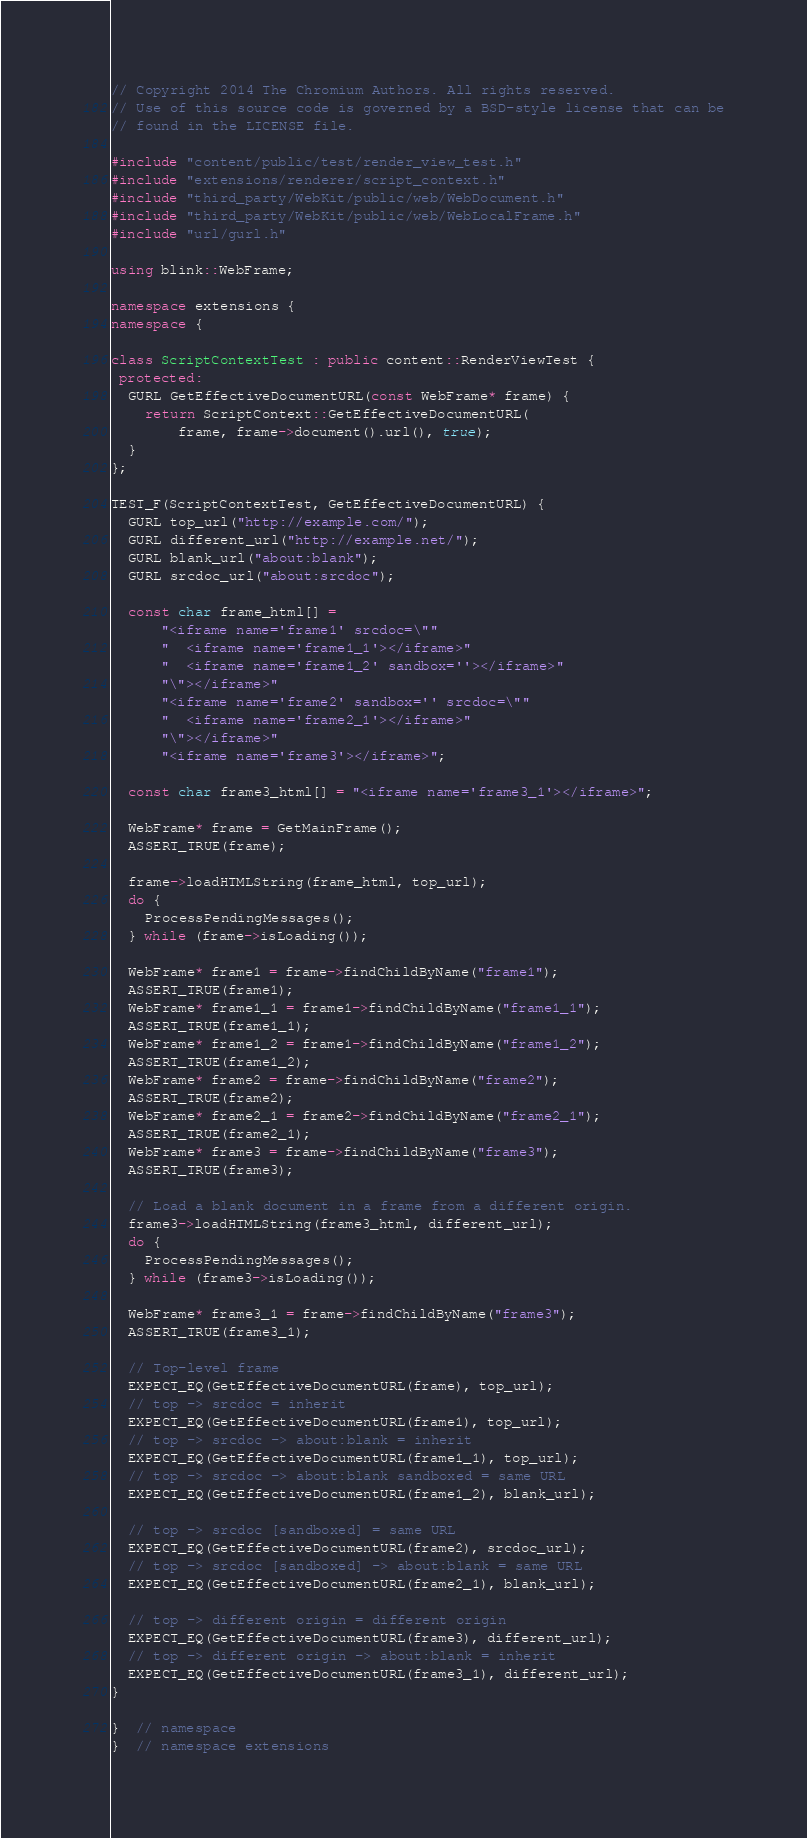<code> <loc_0><loc_0><loc_500><loc_500><_C++_>// Copyright 2014 The Chromium Authors. All rights reserved.
// Use of this source code is governed by a BSD-style license that can be
// found in the LICENSE file.

#include "content/public/test/render_view_test.h"
#include "extensions/renderer/script_context.h"
#include "third_party/WebKit/public/web/WebDocument.h"
#include "third_party/WebKit/public/web/WebLocalFrame.h"
#include "url/gurl.h"

using blink::WebFrame;

namespace extensions {
namespace {

class ScriptContextTest : public content::RenderViewTest {
 protected:
  GURL GetEffectiveDocumentURL(const WebFrame* frame) {
    return ScriptContext::GetEffectiveDocumentURL(
        frame, frame->document().url(), true);
  }
};

TEST_F(ScriptContextTest, GetEffectiveDocumentURL) {
  GURL top_url("http://example.com/");
  GURL different_url("http://example.net/");
  GURL blank_url("about:blank");
  GURL srcdoc_url("about:srcdoc");

  const char frame_html[] =
      "<iframe name='frame1' srcdoc=\""
      "  <iframe name='frame1_1'></iframe>"
      "  <iframe name='frame1_2' sandbox=''></iframe>"
      "\"></iframe>"
      "<iframe name='frame2' sandbox='' srcdoc=\""
      "  <iframe name='frame2_1'></iframe>"
      "\"></iframe>"
      "<iframe name='frame3'></iframe>";

  const char frame3_html[] = "<iframe name='frame3_1'></iframe>";

  WebFrame* frame = GetMainFrame();
  ASSERT_TRUE(frame);

  frame->loadHTMLString(frame_html, top_url);
  do {
    ProcessPendingMessages();
  } while (frame->isLoading());

  WebFrame* frame1 = frame->findChildByName("frame1");
  ASSERT_TRUE(frame1);
  WebFrame* frame1_1 = frame1->findChildByName("frame1_1");
  ASSERT_TRUE(frame1_1);
  WebFrame* frame1_2 = frame1->findChildByName("frame1_2");
  ASSERT_TRUE(frame1_2);
  WebFrame* frame2 = frame->findChildByName("frame2");
  ASSERT_TRUE(frame2);
  WebFrame* frame2_1 = frame2->findChildByName("frame2_1");
  ASSERT_TRUE(frame2_1);
  WebFrame* frame3 = frame->findChildByName("frame3");
  ASSERT_TRUE(frame3);

  // Load a blank document in a frame from a different origin.
  frame3->loadHTMLString(frame3_html, different_url);
  do {
    ProcessPendingMessages();
  } while (frame3->isLoading());

  WebFrame* frame3_1 = frame->findChildByName("frame3");
  ASSERT_TRUE(frame3_1);

  // Top-level frame
  EXPECT_EQ(GetEffectiveDocumentURL(frame), top_url);
  // top -> srcdoc = inherit
  EXPECT_EQ(GetEffectiveDocumentURL(frame1), top_url);
  // top -> srcdoc -> about:blank = inherit
  EXPECT_EQ(GetEffectiveDocumentURL(frame1_1), top_url);
  // top -> srcdoc -> about:blank sandboxed = same URL
  EXPECT_EQ(GetEffectiveDocumentURL(frame1_2), blank_url);

  // top -> srcdoc [sandboxed] = same URL
  EXPECT_EQ(GetEffectiveDocumentURL(frame2), srcdoc_url);
  // top -> srcdoc [sandboxed] -> about:blank = same URL
  EXPECT_EQ(GetEffectiveDocumentURL(frame2_1), blank_url);

  // top -> different origin = different origin
  EXPECT_EQ(GetEffectiveDocumentURL(frame3), different_url);
  // top -> different origin -> about:blank = inherit
  EXPECT_EQ(GetEffectiveDocumentURL(frame3_1), different_url);
}

}  // namespace
}  // namespace extensions
</code> 